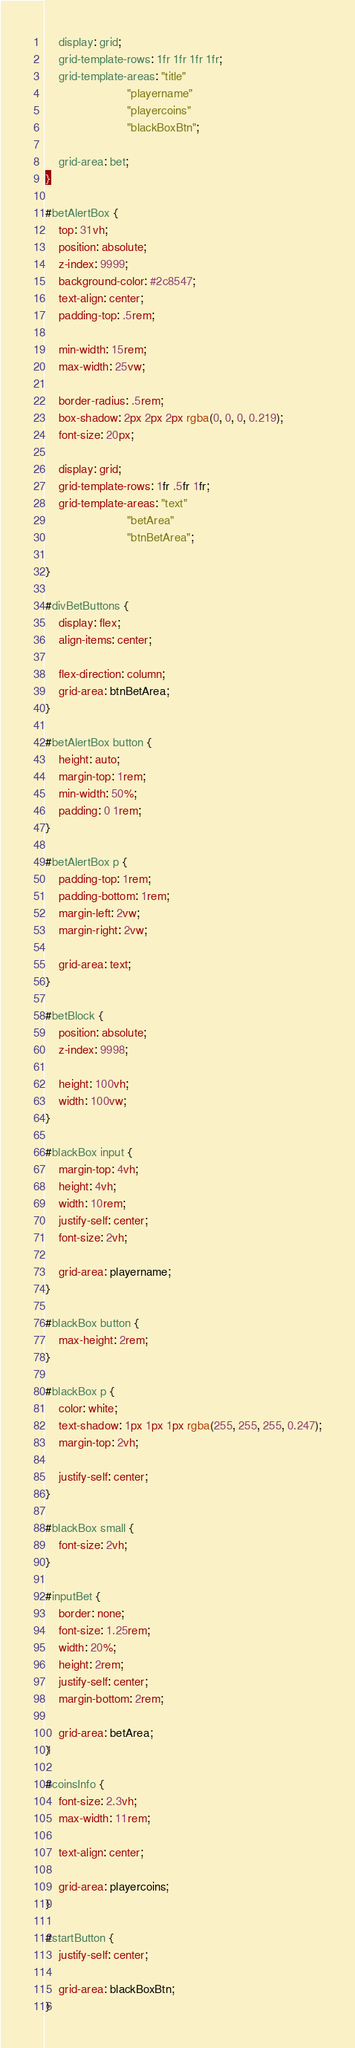<code> <loc_0><loc_0><loc_500><loc_500><_CSS_>    display: grid;
    grid-template-rows: 1fr 1fr 1fr 1fr;
    grid-template-areas: "title"
                         "playername"
                         "playercoins"
                         "blackBoxBtn";

    grid-area: bet;
}

#betAlertBox {
    top: 31vh;
    position: absolute;
    z-index: 9999;
    background-color: #2c8547;
    text-align: center;
    padding-top: .5rem;

    min-width: 15rem;
    max-width: 25vw;

    border-radius: .5rem;
    box-shadow: 2px 2px 2px rgba(0, 0, 0, 0.219);
    font-size: 20px;

    display: grid;
    grid-template-rows: 1fr .5fr 1fr;
    grid-template-areas: "text"
                         "betArea"
                         "btnBetArea";
    
}

#divBetButtons {
    display: flex;
    align-items: center;

    flex-direction: column;
    grid-area: btnBetArea;
}

#betAlertBox button {
    height: auto;
    margin-top: 1rem;
    min-width: 50%;
    padding: 0 1rem;
}

#betAlertBox p {
    padding-top: 1rem;
    padding-bottom: 1rem;
    margin-left: 2vw;
    margin-right: 2vw;

    grid-area: text;
}

#betBlock {
    position: absolute;
    z-index: 9998;

    height: 100vh;
    width: 100vw;
}

#blackBox input {
    margin-top: 4vh;
    height: 4vh;
    width: 10rem;
    justify-self: center;
    font-size: 2vh;

    grid-area: playername;
}

#blackBox button {
    max-height: 2rem;
}

#blackBox p {
    color: white;
    text-shadow: 1px 1px 1px rgba(255, 255, 255, 0.247);
    margin-top: 2vh;

    justify-self: center;
}

#blackBox small {
    font-size: 2vh;
}

#inputBet {
    border: none;
    font-size: 1.25rem;
    width: 20%;
    height: 2rem;
    justify-self: center;
    margin-bottom: 2rem;

    grid-area: betArea;
}

#coinsInfo {
    font-size: 2.3vh;
    max-width: 11rem;

    text-align: center;

    grid-area: playercoins;
}

#startButton {
    justify-self: center;

    grid-area: blackBoxBtn;
}</code> 